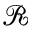Convert formula to latex. <formula><loc_0><loc_0><loc_500><loc_500>\mathcal { R }</formula> 